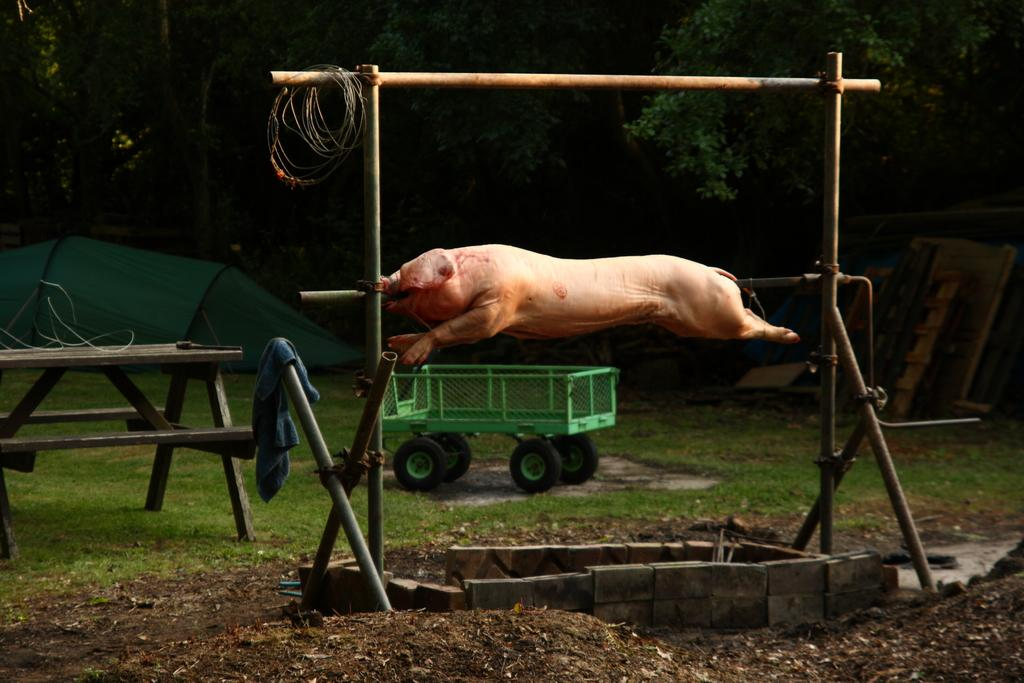What animal is the main subject of the image? There is a pig in the image. How is the pig being prepared in the image? The pig is on a roller for roasting. What can be seen behind the pig in the image? There is a vehicle behind the pig. What type of natural environment is visible in the image? Trees are visible in the image. Can you see a playground in the image? There is no playground present in the image. Is there a spy observing the pig in the image? There is no indication of a spy or any person observing the pig in the image. 